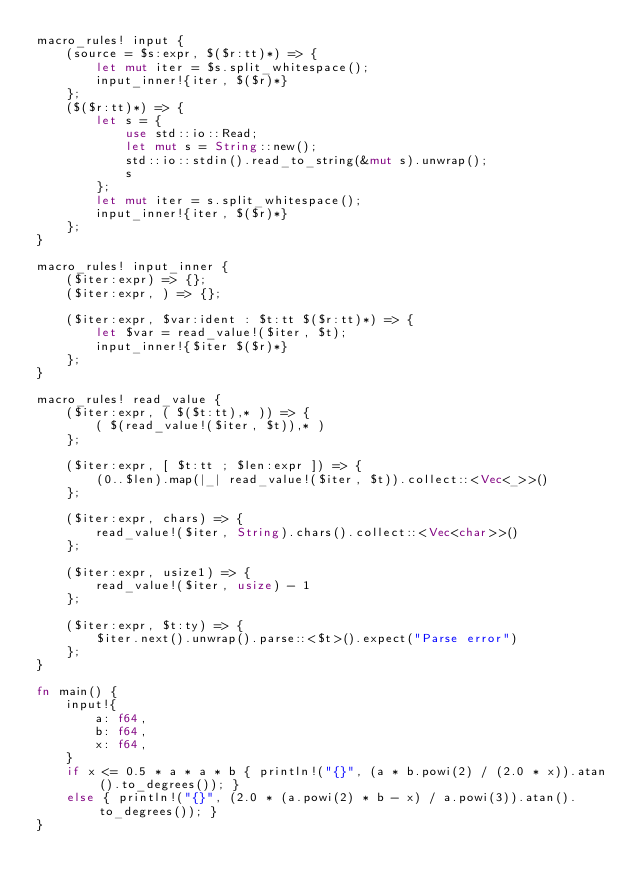Convert code to text. <code><loc_0><loc_0><loc_500><loc_500><_Rust_>macro_rules! input {
    (source = $s:expr, $($r:tt)*) => {
        let mut iter = $s.split_whitespace();
        input_inner!{iter, $($r)*}
    };
    ($($r:tt)*) => {
        let s = {
            use std::io::Read;
            let mut s = String::new();
            std::io::stdin().read_to_string(&mut s).unwrap();
            s
        };
        let mut iter = s.split_whitespace();
        input_inner!{iter, $($r)*}
    };
}

macro_rules! input_inner {
    ($iter:expr) => {};
    ($iter:expr, ) => {};

    ($iter:expr, $var:ident : $t:tt $($r:tt)*) => {
        let $var = read_value!($iter, $t);
        input_inner!{$iter $($r)*}
    };
}

macro_rules! read_value {
    ($iter:expr, ( $($t:tt),* )) => {
        ( $(read_value!($iter, $t)),* )
    };

    ($iter:expr, [ $t:tt ; $len:expr ]) => {
        (0..$len).map(|_| read_value!($iter, $t)).collect::<Vec<_>>()
    };

    ($iter:expr, chars) => {
        read_value!($iter, String).chars().collect::<Vec<char>>()
    };

    ($iter:expr, usize1) => {
        read_value!($iter, usize) - 1
    };

    ($iter:expr, $t:ty) => {
        $iter.next().unwrap().parse::<$t>().expect("Parse error")
    };
}

fn main() {
    input!{
        a: f64,
        b: f64,
        x: f64,
    }
    if x <= 0.5 * a * a * b { println!("{}", (a * b.powi(2) / (2.0 * x)).atan().to_degrees()); }
    else { println!("{}", (2.0 * (a.powi(2) * b - x) / a.powi(3)).atan().to_degrees()); }
}
</code> 